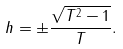Convert formula to latex. <formula><loc_0><loc_0><loc_500><loc_500>h = \pm \frac { \sqrt { T ^ { 2 } - 1 } } { T } .</formula> 